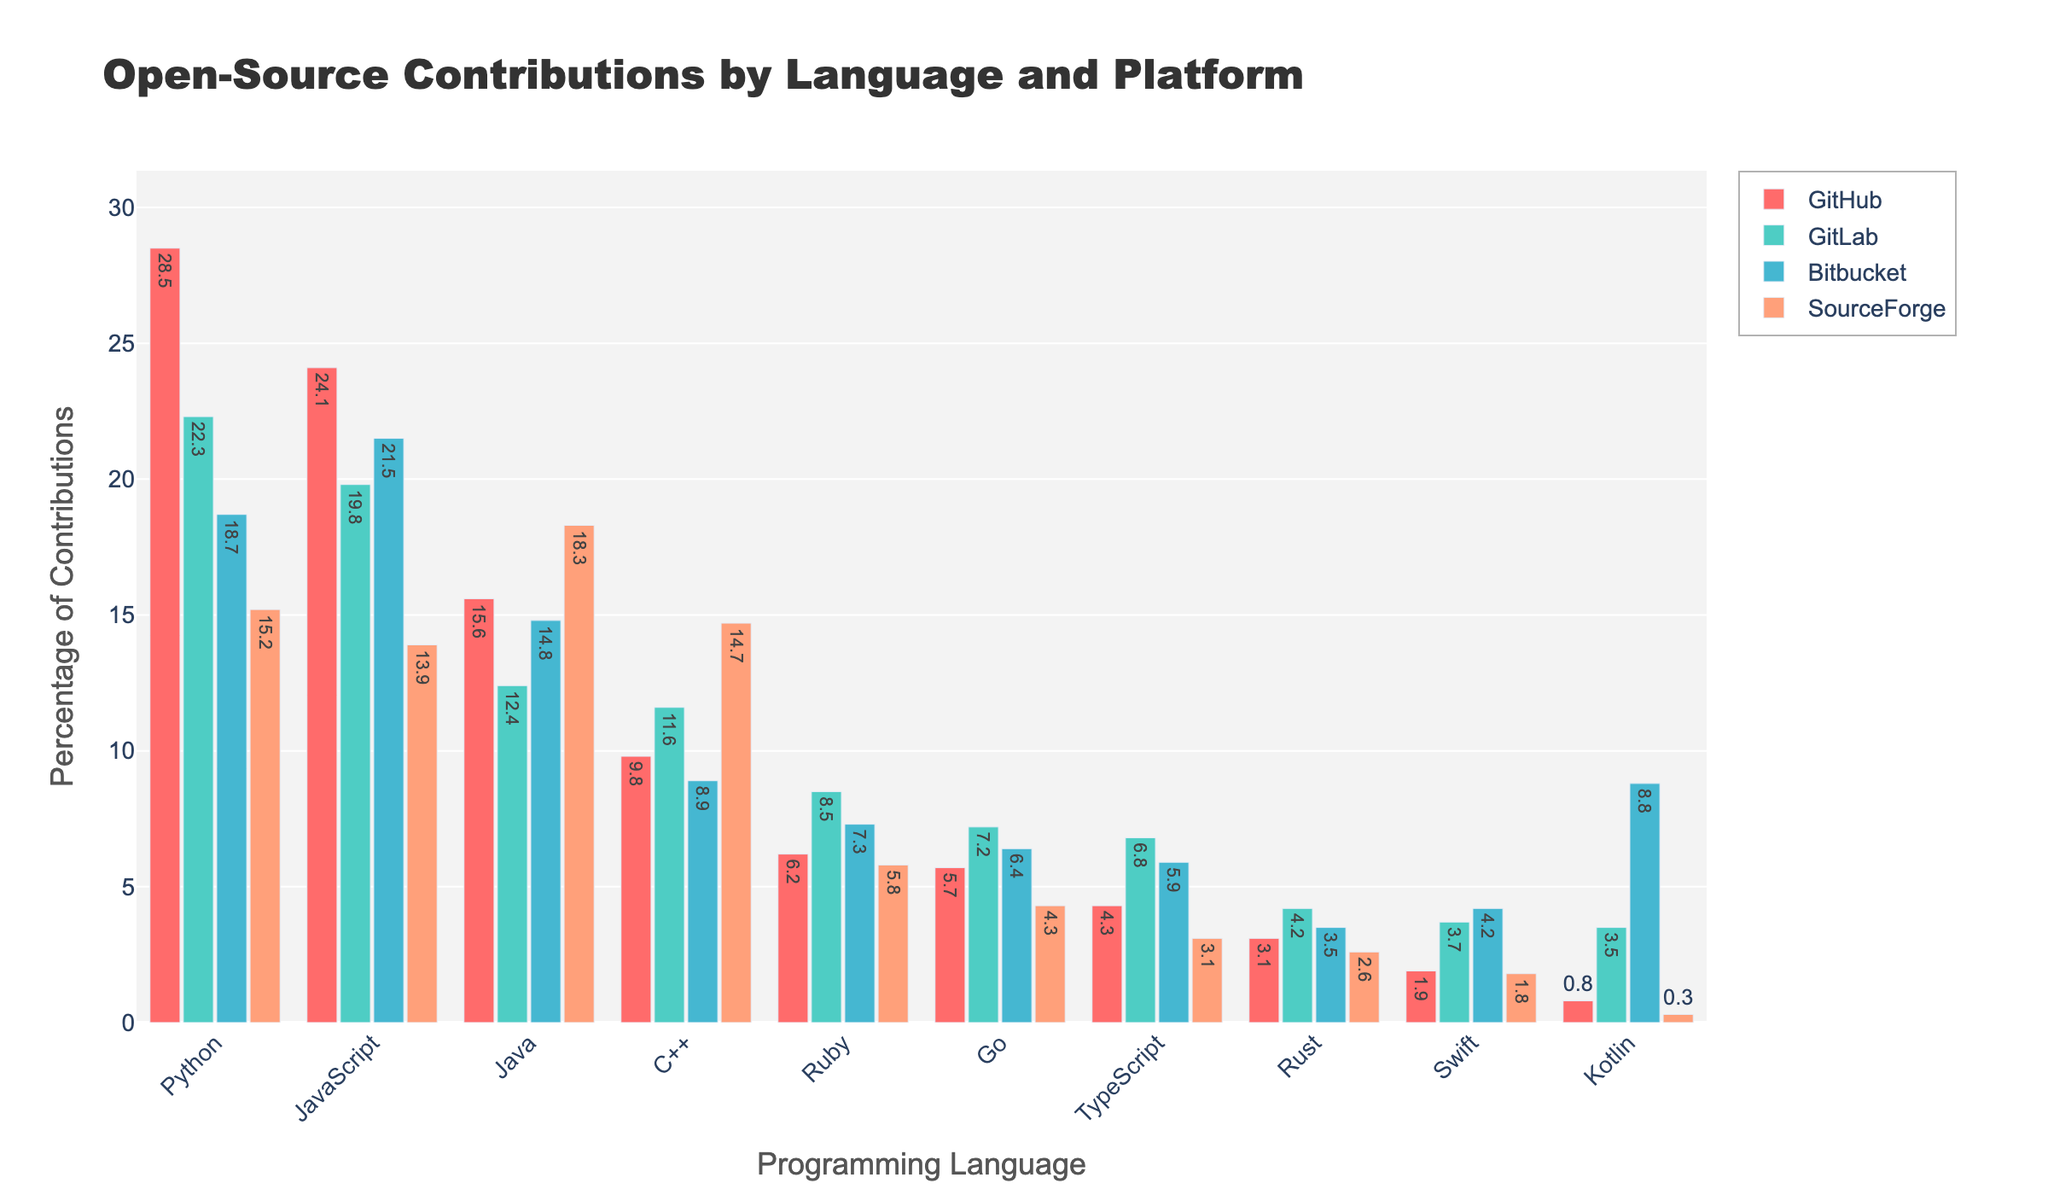Which programming language has the highest percentage of contributions on GitHub? Look at the bar heights for each programming language under the GitHub section. Python has the highest bar.
Answer: Python Which platform has the highest percentage of contributions for JavaScript? Compare the bar heights for JavaScript across all platforms. GitHub has the highest bar.
Answer: GitHub What is the difference in the percentage of contributions for C++ between GitHub and SourceForge? Subtract the percentage of C++ on SourceForge from the percentage on GitHub. 14.7% - 9.8% = 4.9%.
Answer: 4.9% Which language shows more contributions on GitLab, Ruby or Swift? Compare the heights of Ruby and Swift bars on GitLab. Ruby has a higher bar height.
Answer: Ruby What is the combined percentage of contributions for Python on GitHub, GitLab, and Bitbucket? Sum the percentages for Python on these three platforms. 28.5% + 22.3% + 18.7% = 69.5%
Answer: 69.5% Is the percentage of contributions for Rust on Bitbucket higher or lower than Swift on the same platform? Compare the heights of Rust and Swift bars on Bitbucket. Swift has a higher percentage.
Answer: Lower Which language has the closest contribution percentage on GitHub and Bitbucket? Measure the difference for each language between GitHub and Bitbucket, then find the smallest difference. JavaScript is 24.1% on GitHub and 21.5% on Bitbucket – a difference of 2.6%, which is the smallest among all languages.
Answer: JavaScript What is the average percentage of contributions for Go across all platforms? Add the percentages for Go on all platforms and divide by the number of platforms. (5.7% + 7.2% + 6.4% + 4.3%) / 4 = 5.9%
Answer: 5.9% Which platform exhibits the most variation in contribution percentages across different languages? Calculate the range (maximum - minimum percentage) for each platform. GitHub range is: 28.5% - 0.8% = 27.7%, GitLab: 22.3% - 3.5% = 18.8%, Bitbucket: 21.5% - 3.5% = 18.0%, SourceForge: 18.3% - 0.3% = 18.0%. GitHub has the largest range.
Answer: GitHub For Kotlin, on which platform does the percentage difference with SourceForge is the largest? Calculate the difference between percentages of Kotlin on each platform with SourceForge. GitHub: 0.8 - 0.3 = 0.5, GitLab: 3.5 - 0.3 = 3.2, Bitbucket: 8.8 - 0.3 = 8.5. Bitbucket has the largest difference.
Answer: Bitbucket 